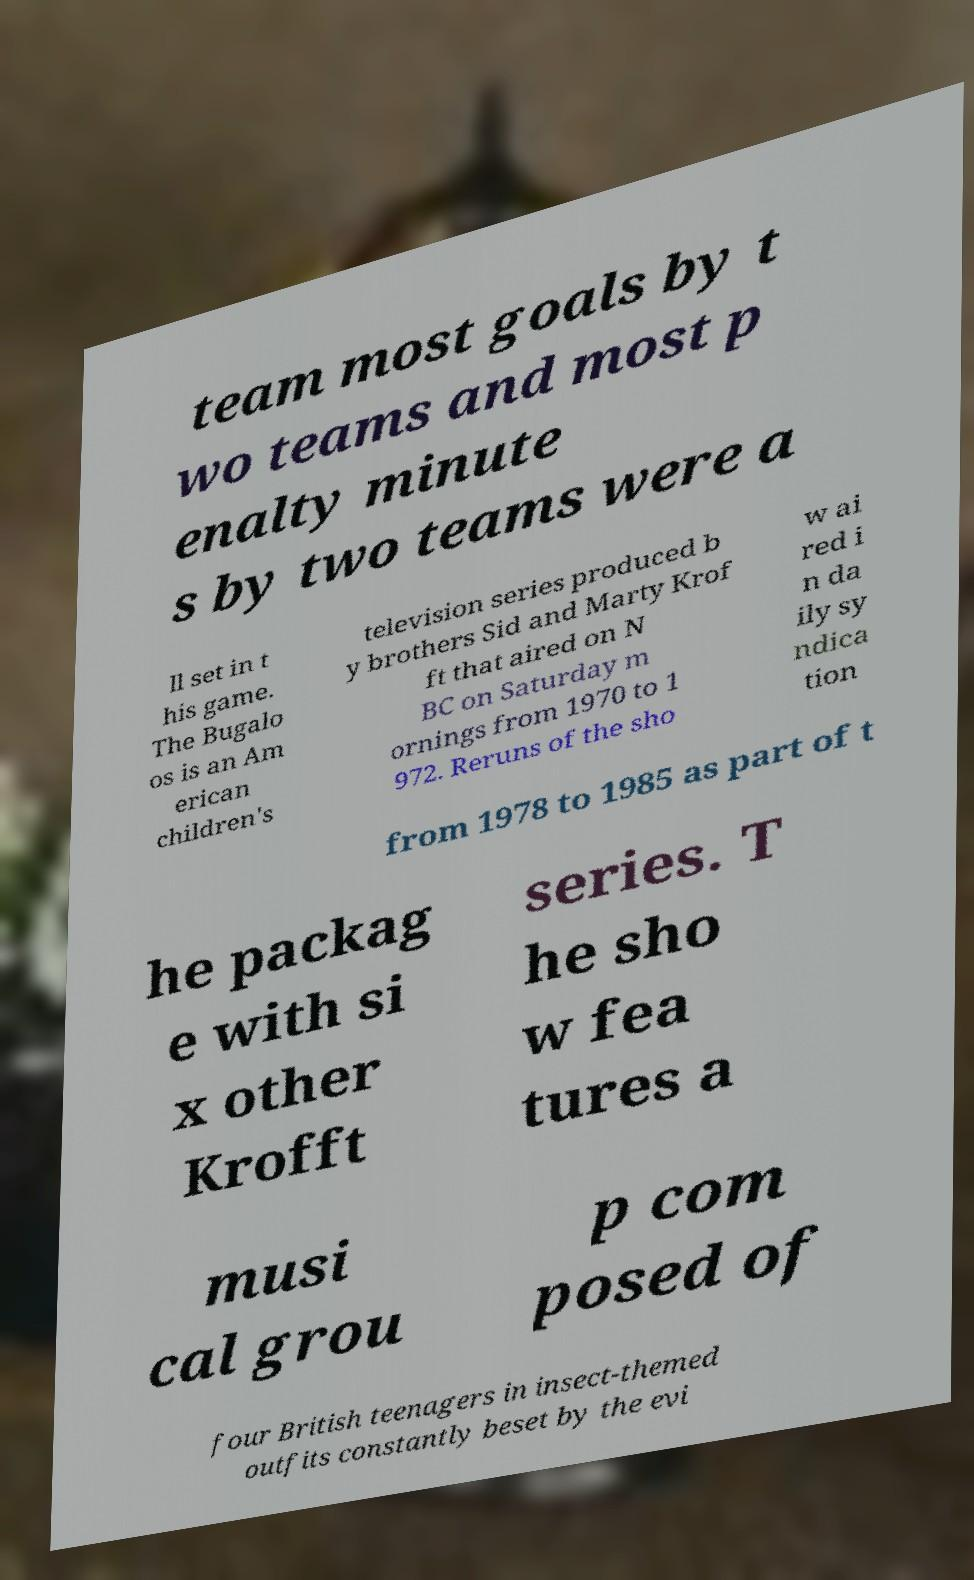Can you read and provide the text displayed in the image?This photo seems to have some interesting text. Can you extract and type it out for me? team most goals by t wo teams and most p enalty minute s by two teams were a ll set in t his game. The Bugalo os is an Am erican children's television series produced b y brothers Sid and Marty Krof ft that aired on N BC on Saturday m ornings from 1970 to 1 972. Reruns of the sho w ai red i n da ily sy ndica tion from 1978 to 1985 as part of t he packag e with si x other Krofft series. T he sho w fea tures a musi cal grou p com posed of four British teenagers in insect-themed outfits constantly beset by the evi 